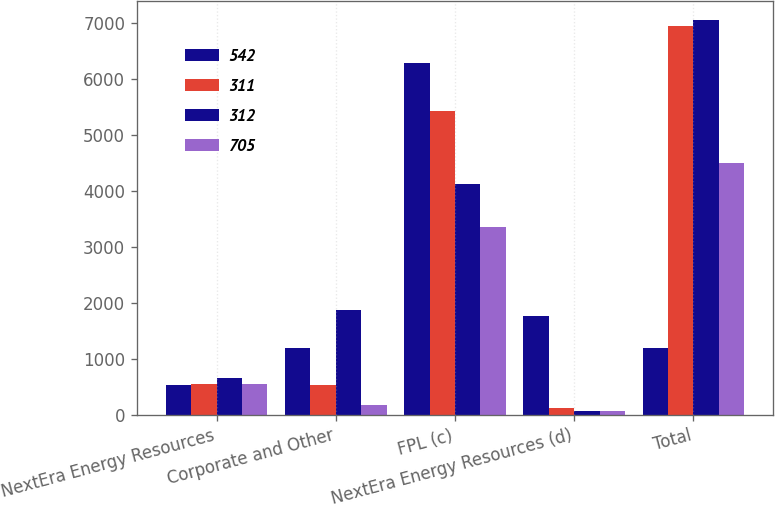Convert chart to OTSL. <chart><loc_0><loc_0><loc_500><loc_500><stacked_bar_chart><ecel><fcel>NextEra Energy Resources<fcel>Corporate and Other<fcel>FPL (c)<fcel>NextEra Energy Resources (d)<fcel>Total<nl><fcel>542<fcel>544<fcel>1195<fcel>6270<fcel>1760<fcel>1195<nl><fcel>311<fcel>549<fcel>533<fcel>5425<fcel>120<fcel>6938<nl><fcel>312<fcel>656<fcel>1874<fcel>4120<fcel>75<fcel>7037<nl><fcel>705<fcel>548<fcel>187<fcel>3360<fcel>75<fcel>4486<nl></chart> 